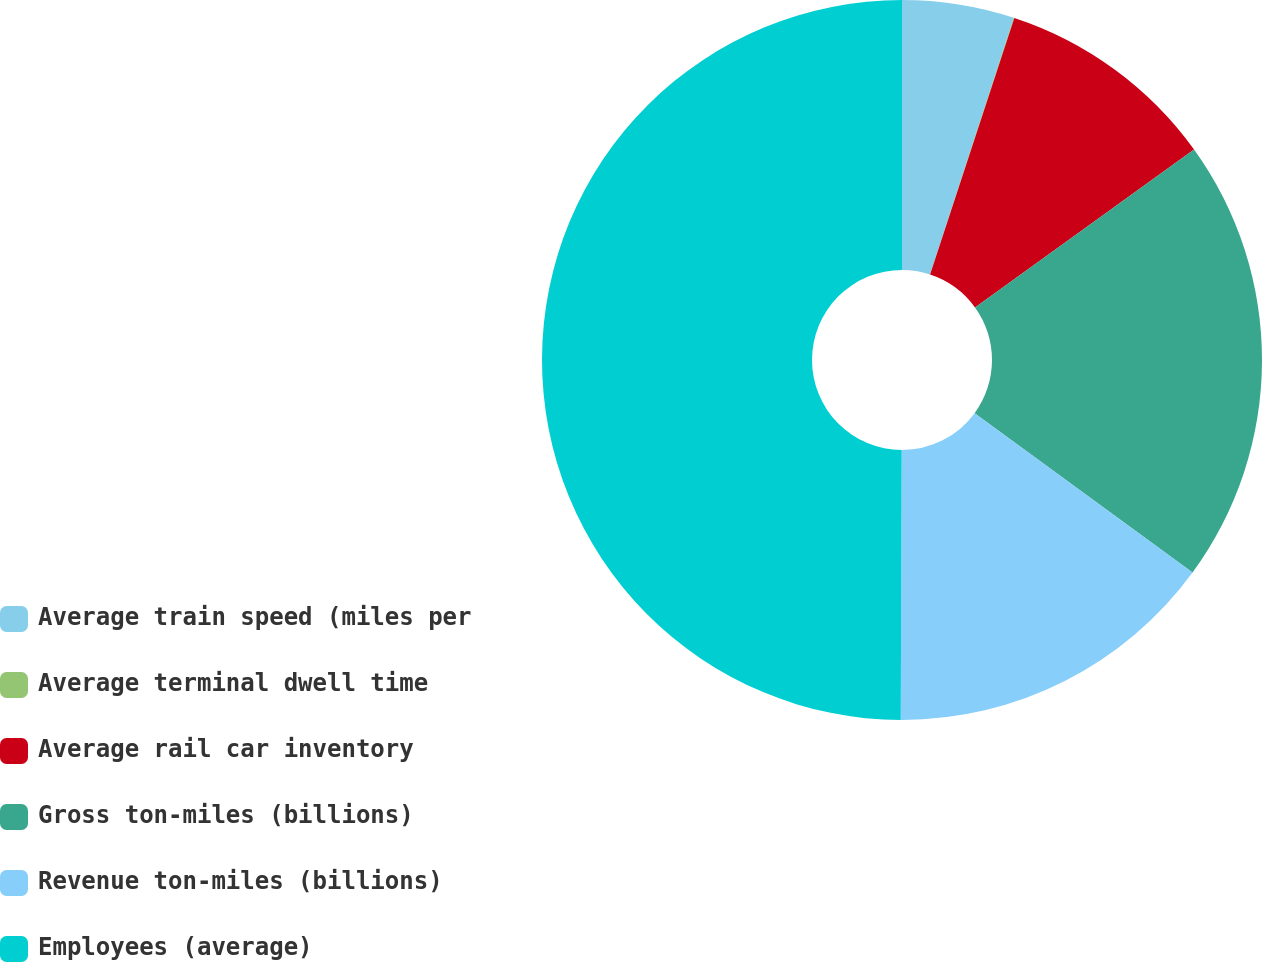Convert chart to OTSL. <chart><loc_0><loc_0><loc_500><loc_500><pie_chart><fcel>Average train speed (miles per<fcel>Average terminal dwell time<fcel>Average rail car inventory<fcel>Gross ton-miles (billions)<fcel>Revenue ton-miles (billions)<fcel>Employees (average)<nl><fcel>5.02%<fcel>0.03%<fcel>10.01%<fcel>19.99%<fcel>15.0%<fcel>49.94%<nl></chart> 